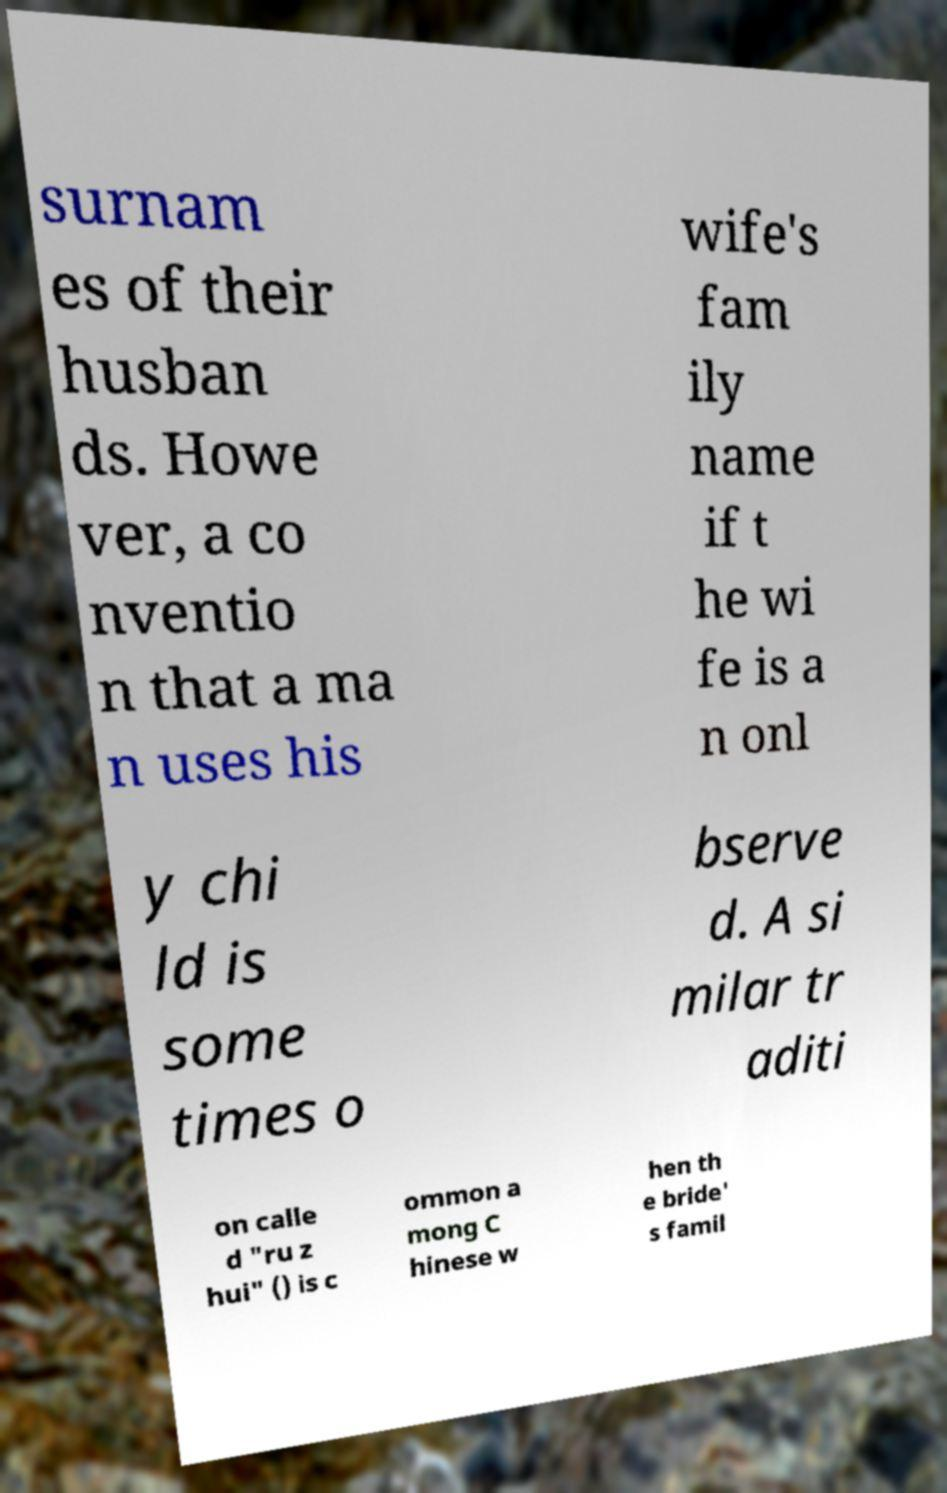Could you assist in decoding the text presented in this image and type it out clearly? surnam es of their husban ds. Howe ver, a co nventio n that a ma n uses his wife's fam ily name if t he wi fe is a n onl y chi ld is some times o bserve d. A si milar tr aditi on calle d "ru z hui" () is c ommon a mong C hinese w hen th e bride' s famil 